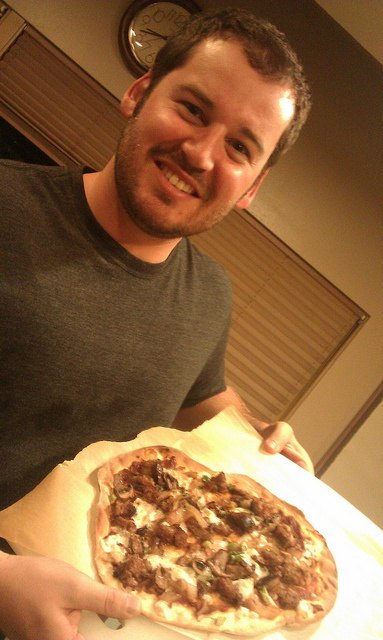Describe the objects in this image and their specific colors. I can see people in black, maroon, and brown tones, pizza in black, orange, brown, khaki, and red tones, and clock in black, maroon, and brown tones in this image. 